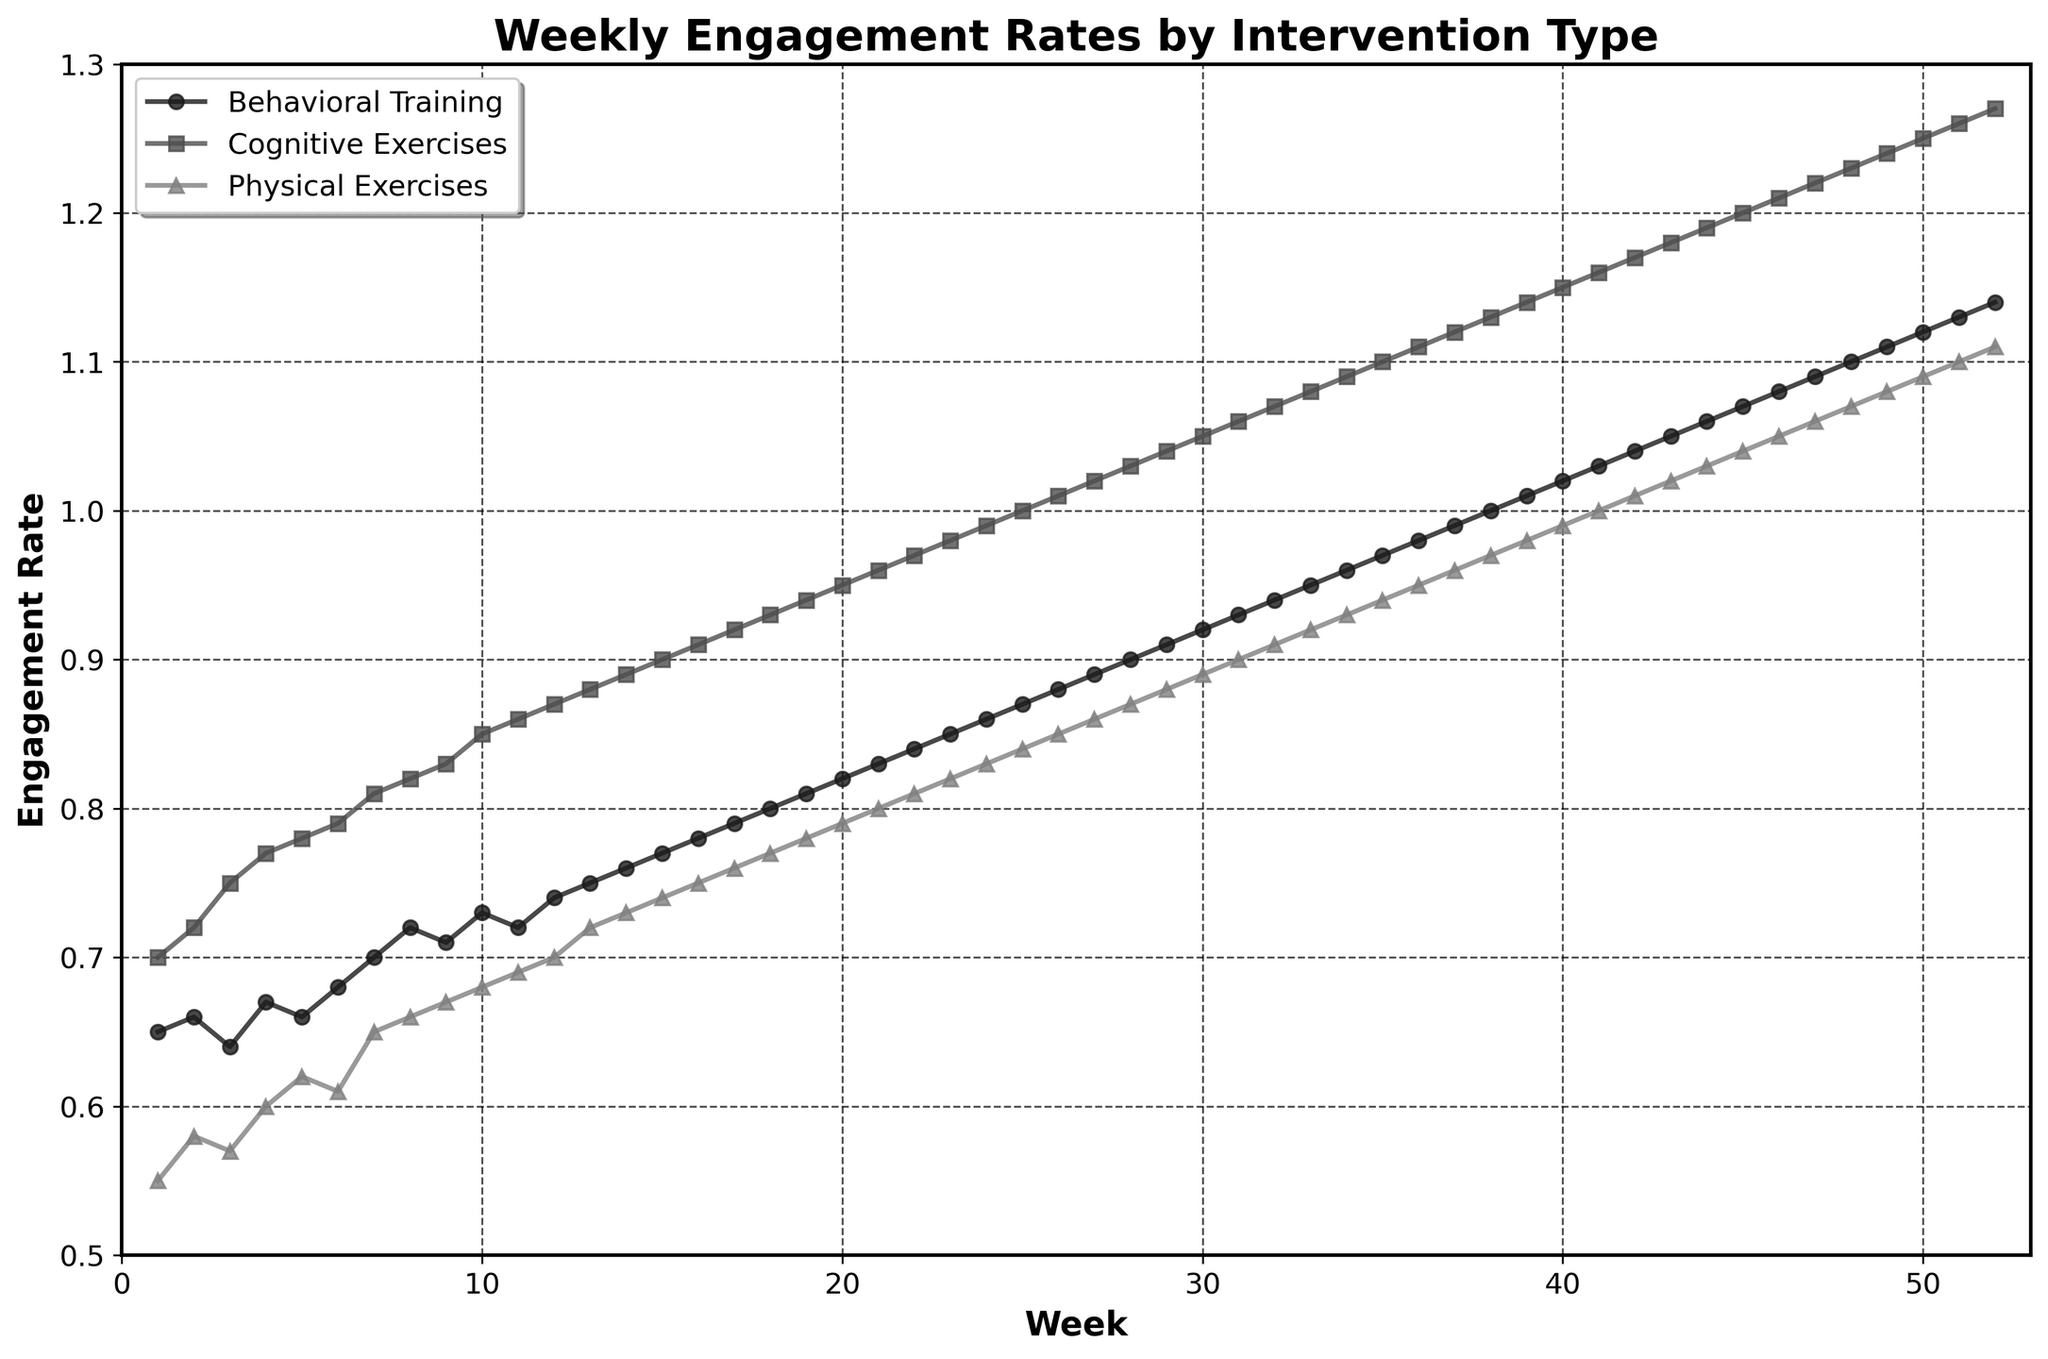Which intervention has the highest engagement rate in week 10? In week 10, the engagement rates for the interventions are visible as different markers along the x-axis. Cognitive Exercises has the highest point.
Answer: Cognitive Exercises What is the title of the plot? The title is displayed at the top of the figure in bold font.
Answer: Weekly Engagement Rates by Intervention Type How many weeks does the study cover? The x-axis shows weeks from number 1 to 52, indicating the length of the study.
Answer: 52 Which intervention has the lowest initial engagement rate? In week 1, the engagement rates can be compared to see that Physical Exercises has the lowest engagement rate.
Answer: Physical Exercises By how much does the engagement rate of Behavioral Training change from week 15 to week 52? In week 15, the engagement rate for Behavioral Training is 0.77, and in week 52, it is 1.14. The difference is calculated as 1.14 - 0.77.
Answer: 0.37 In which weeks do Cognitive Exercises and Behavioral Training reach an engagement rate of 1.0? Cognitive Exercises reaches 1.0 in week 25, and Behavioral Training reaches 1.0 in week 38.
Answer: 25 and 38 What is the average engagement rate of Physical Exercises over the study period? Sum all the engagement rates for Physical Exercises over 52 weeks and divide by 52 to get the average. [Note: It's suggested to use a calculator or software for the exact sum and division.]
Answer: approximately 0.88 Which intervention shows the steepest increase in engagement rate over the first 10 weeks? Comparing the slopes of the lines over the first 10 weeks, Cognitive Exercises shows the sharpest rise.
Answer: Cognitive Exercises How do engagement rates of Physical Exercises change between weeks 30 and 40? Between weeks 30 and 40, the engagement rate of Physical Exercises increases from 0.89 to 0.99. Calculate the change as 0.99 - 0.89.
Answer: 0.10 By the end of the study, which intervention has the highest engagement rate? Towards the end of the x-axis, Cognitive Exercises shows the highest engagement rate point.
Answer: Cognitive Exercises 